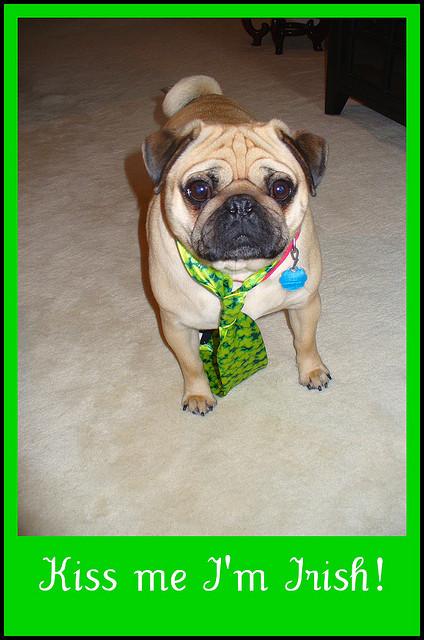What color is the dog?
Write a very short answer. Tan. What piece of human clothing is the dog wearing?
Write a very short answer. Tie. What breed of dog is this?
Answer briefly. Pug. 